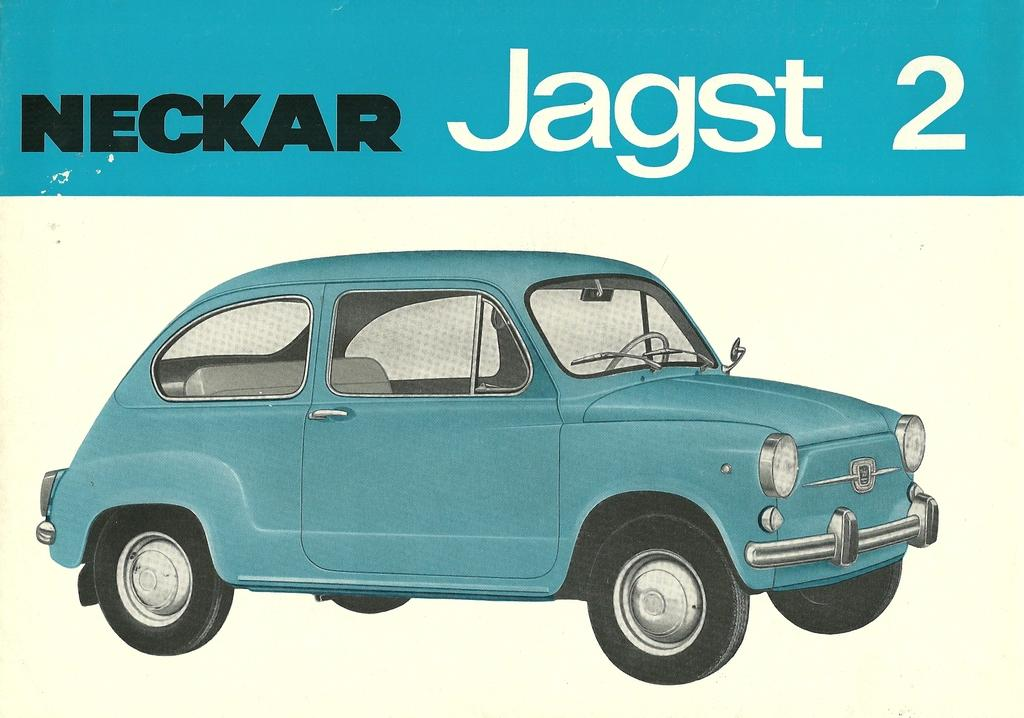What color is the car in the image? The car in the image is blue. What else can be seen in the image besides the car? There is some text visible in the image. How many nails are used to hold the car together in the image? There are no nails visible in the image, and the car's construction is not mentioned. 